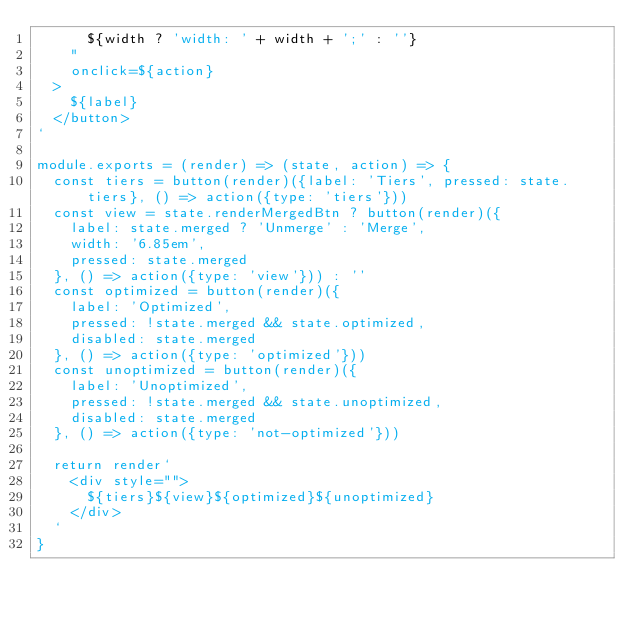<code> <loc_0><loc_0><loc_500><loc_500><_JavaScript_>      ${width ? 'width: ' + width + ';' : ''}
    " 
    onclick=${action}
  >
    ${label}
  </button>
`

module.exports = (render) => (state, action) => {
  const tiers = button(render)({label: 'Tiers', pressed: state.tiers}, () => action({type: 'tiers'}))
  const view = state.renderMergedBtn ? button(render)({
    label: state.merged ? 'Unmerge' : 'Merge',
    width: '6.85em',
    pressed: state.merged
  }, () => action({type: 'view'})) : ''
  const optimized = button(render)({
    label: 'Optimized',
    pressed: !state.merged && state.optimized,
    disabled: state.merged
  }, () => action({type: 'optimized'}))
  const unoptimized = button(render)({
    label: 'Unoptimized',
    pressed: !state.merged && state.unoptimized,
    disabled: state.merged
  }, () => action({type: 'not-optimized'}))

  return render`
    <div style="">
      ${tiers}${view}${optimized}${unoptimized}
    </div>
  `
}
</code> 